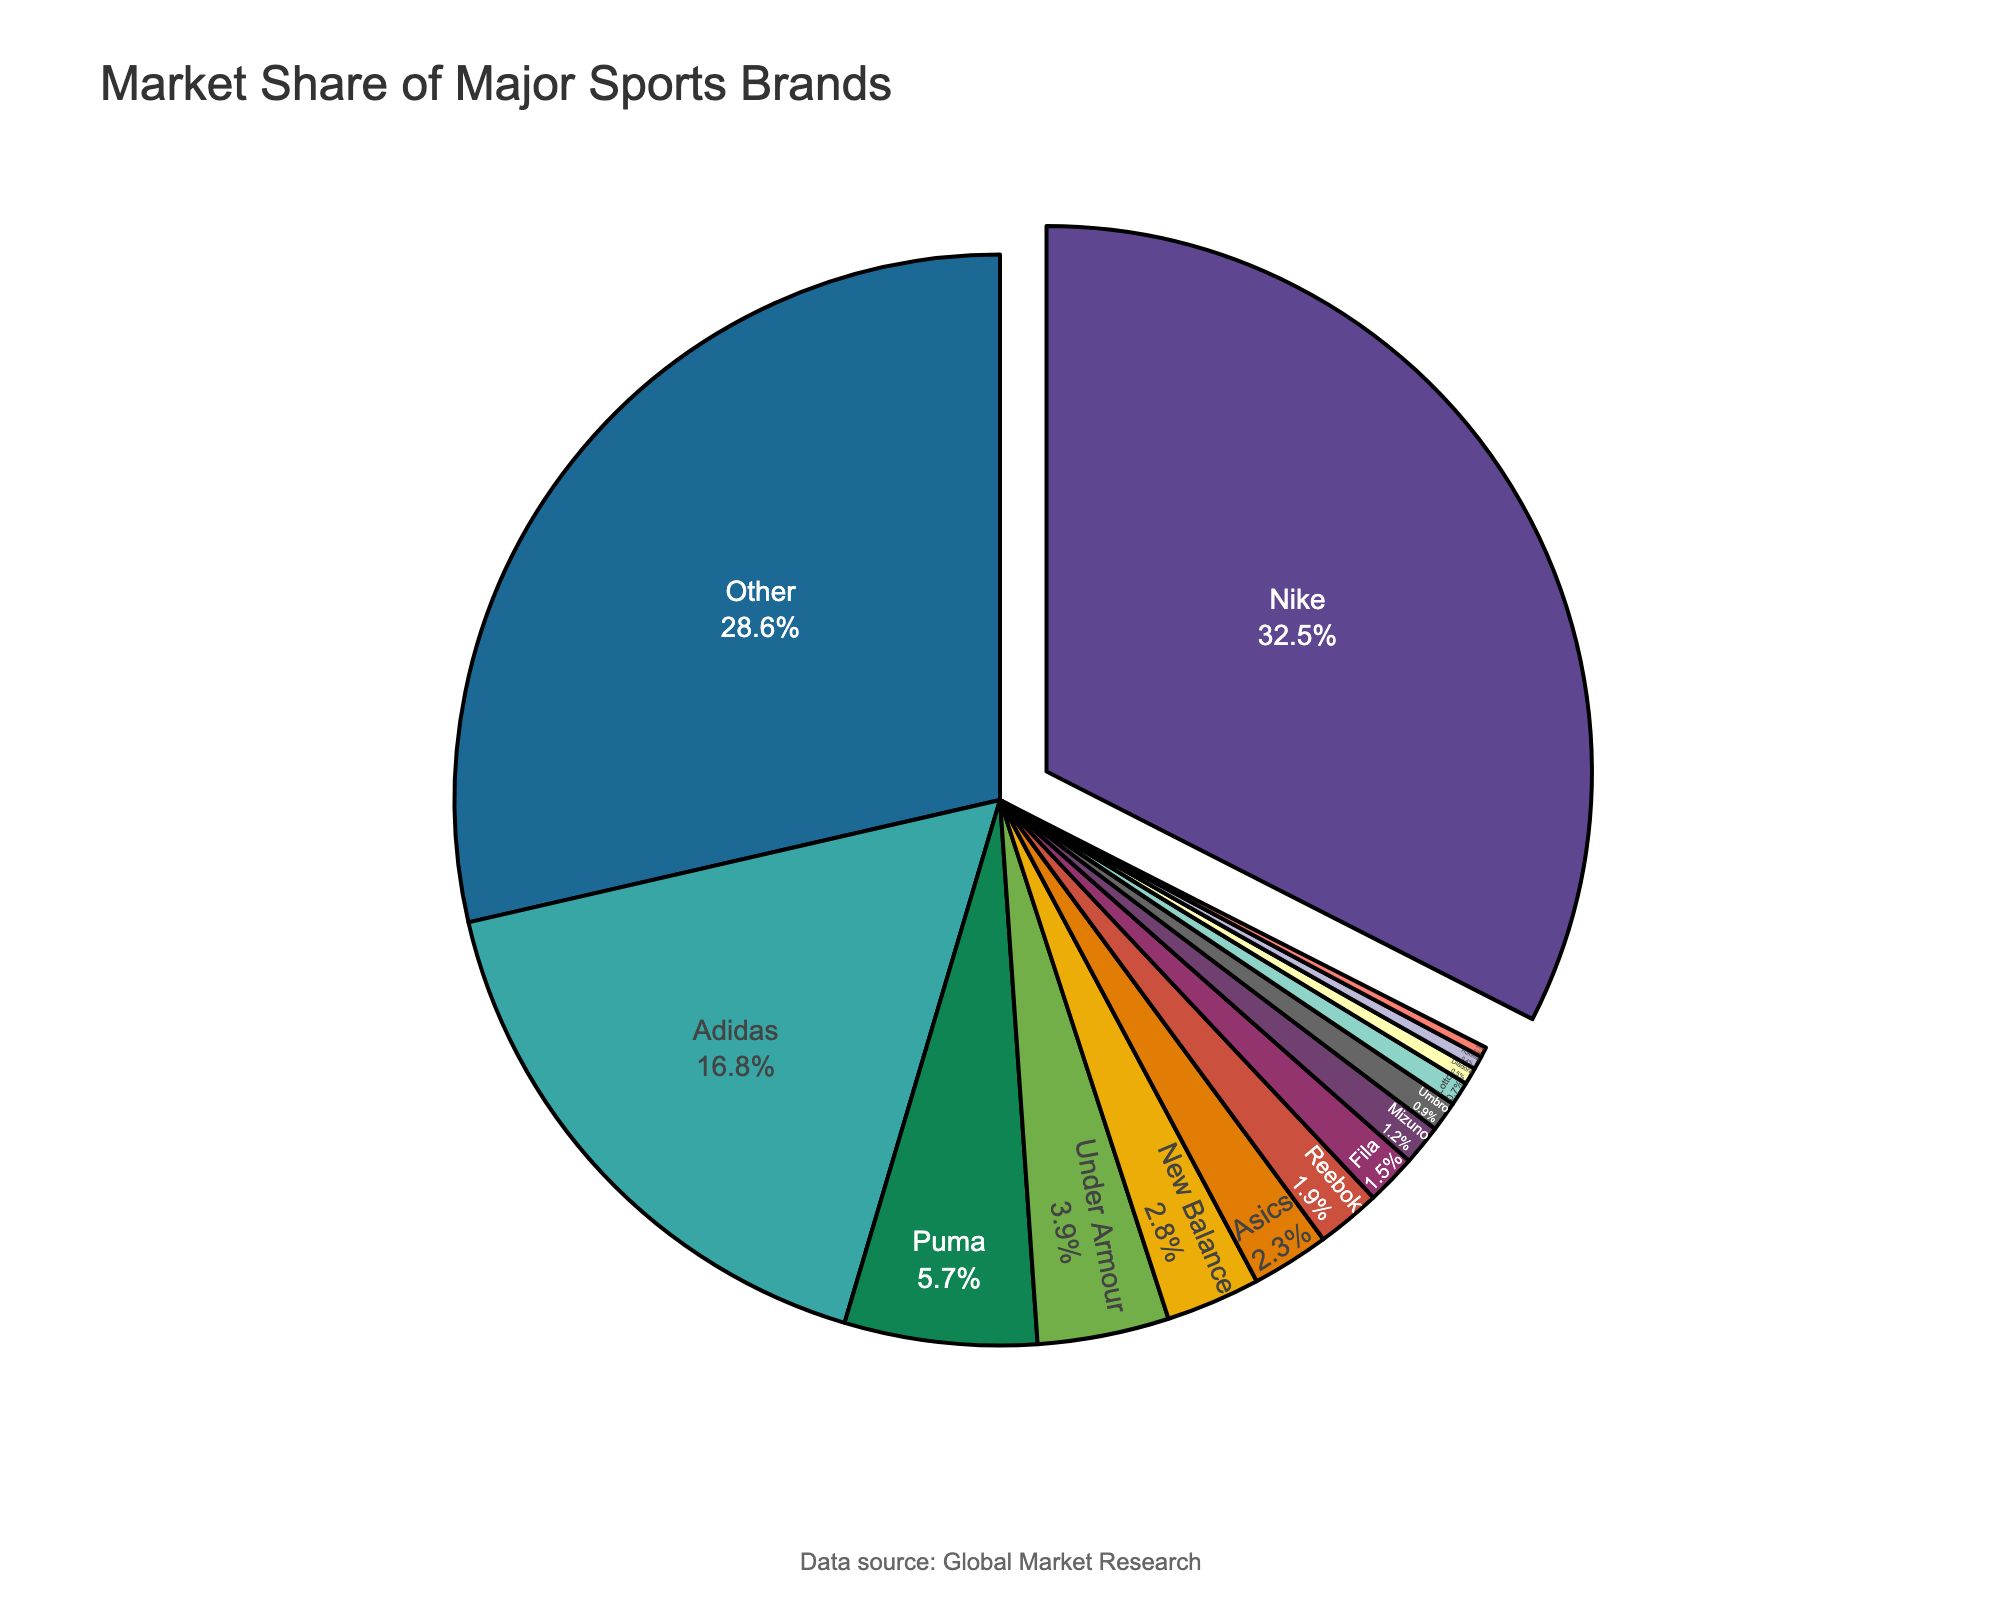Which brand has the highest market share? The brand with the largest slice of the pie chart will have the highest market share. In the figure, Nike has the largest slice.
Answer: Nike What is the total market share of Nike and Adidas combined? Add the market shares of Nike and Adidas from the figure: 32.5% + 16.8%.
Answer: 49.3% Which brands have a market share of less than 2%? Look for the slices of the pie chart that represent less than 2%. These are Reebok (1.9%), Fila (1.5%), Mizuno (1.2%), Umbro (0.9%), Lotto (0.7%), Diadora (0.5%), Hummel (0.4%), and Joma (0.3%).
Answer: Reebok, Fila, Mizuno, Umbro, Lotto, Diadora, Hummel, Joma What is the visual difference between Nike's and Adidas's segments in the chart? Nike's slice is larger and is pulled out slightly from the pie chart to highlight its dominance. Adidas's slice is smaller and stays within the main body of the pie chart.
Answer: Nike's is larger and pulled out How much larger is Nike's market share than Puma's? Subtract Puma's market share from Nike's: 32.5% - 5.7%.
Answer: 26.8% Which three brands together make up the largest market share but less than Nike's alone? Look for combinations of brands whose total share is less than 32.5% but as large as possible. Combining Adidas (16.8%), Under Armour (3.9%), and New Balance (2.8%) gives us 16.8% + 3.9% + 2.8% = 23.5%.
Answer: Adidas, Under Armour, New Balance Compare the combined market share of the brands from Japan (Asics and Mizuno) to the combined share of the brands from the USA (Nike and Under Armour). Add the market shares of Japanese brands (Asics 2.3% + Mizuno 1.2%) and the US brands (Nike 32.5% + Under Armour 3.9%). Compare these two sums: 2.3% + 1.2% = 3.5%, 32.5% + 3.9% = 36.4%.
Answer: USA's is much larger What percentage of the market is occupied by brands other than the top four (Nike, Adidas, Puma, Under Armour)? Subtract the combined market share of the top four brands from 100%: 100% - (32.5% + 16.8% + 5.7% + 3.9%) = 100% - 58.9%.
Answer: 41.1% Which brand has a larger market share, New Balance or Asics, and by how much? Find the difference between their market shares: New Balance (2.8%) - Asics (2.3%).
Answer: New Balance by 0.5% What is the difference between the combined market share of the two largest and two smallest brands shown? Add the market shares of the two largest brands (Nike and Adidas) and subtract the sum of the two smallest (Hummel and Joma): (32.5% + 16.8%) - (0.4% + 0.3%).
Answer: 48.6% 